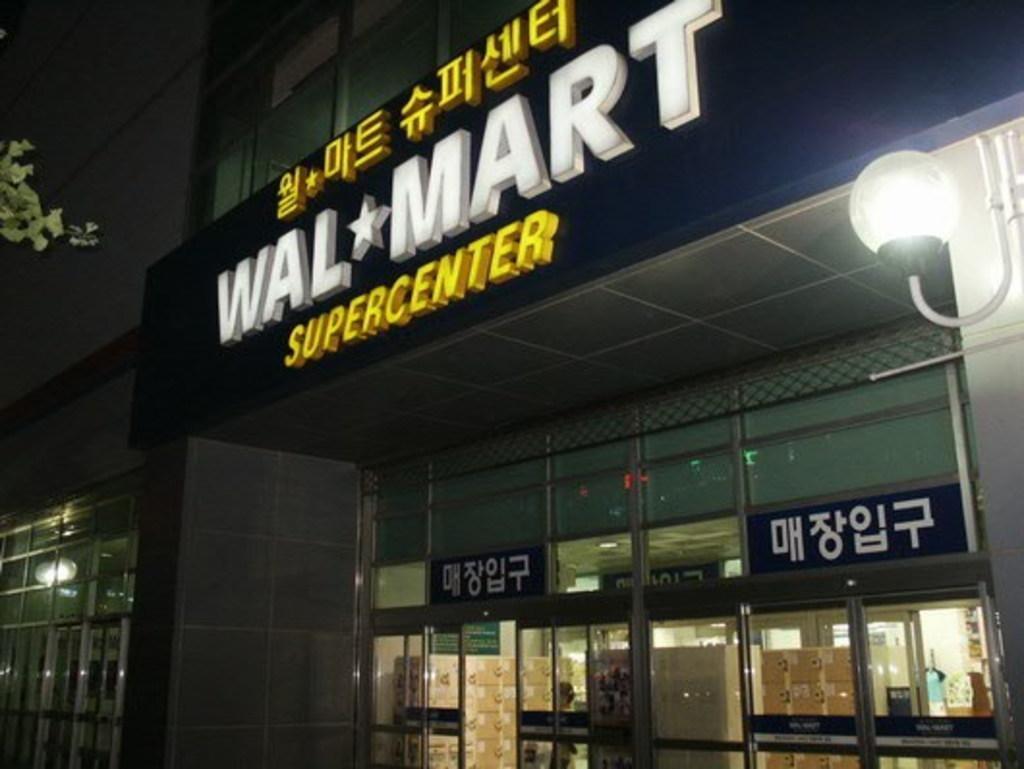Can you describe this image briefly? In this image I can see few buildings, few lights, few boards, few cardboard boxes and a tree. In the background I can see the dark sky. 